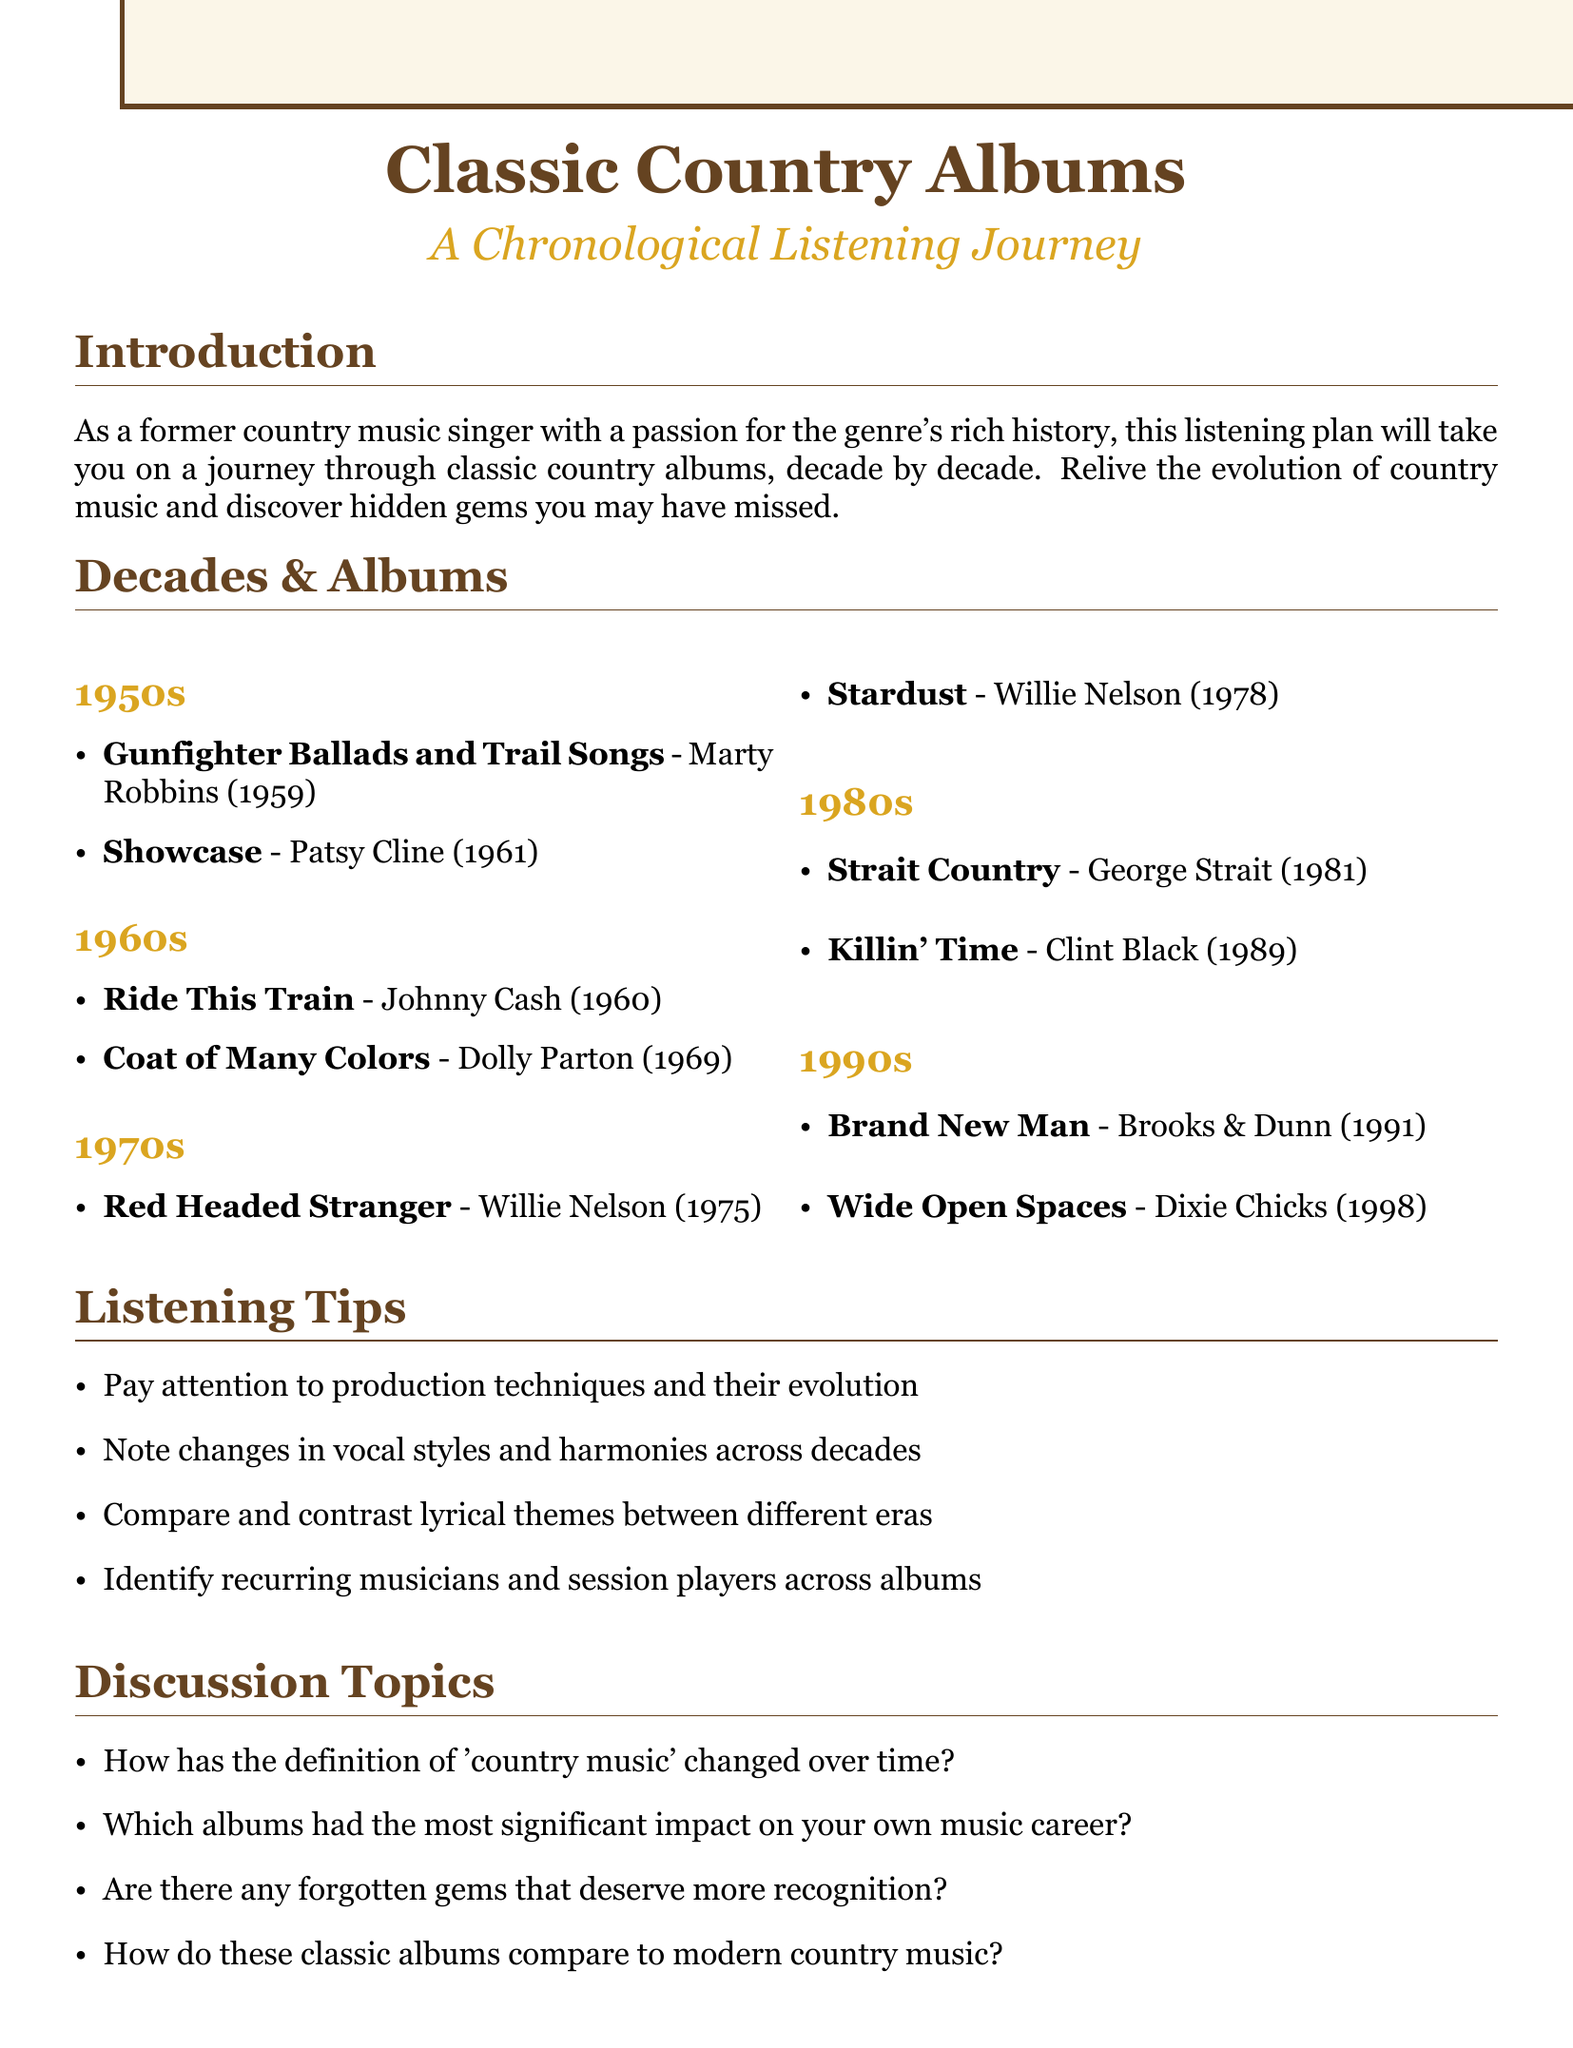What is the title of the listening session plan? The title is explicitly stated at the beginning of the document.
Answer: Chronological Listening Session Plan: Classic Country Albums by Decade Which artist released "Gunfighter Ballads and Trail Songs"? This information can be found under the 1950s album list.
Answer: Marty Robbins In which year was "Red Headed Stranger" released? The year of release is provided alongside the album title in the 1970s section.
Answer: 1975 What are two key tracks from "Coat of Many Colors"? The key tracks are listed in the details of the album.
Answer: Coat of Many Colors, Travelin' Man How many decades are covered in the listening session plan? The document lists a specific number of decades.
Answer: Five What is one listening tip provided in the document? Several tips are listed under the Listening Tips section.
Answer: Pay attention to the production techniques and how they evolve over time Which album is mentioned as part of the 1980s decade? This information is found in the 1980s section of the document.
Answer: Strait Country Name one discussion topic from the document. The discussion topics are enumerated in the corresponding section of the document.
Answer: How has the definition of 'country music' changed over time? What is included in the additional activities section? The document outlines specific activities to engage with the music further.
Answer: Create a playlist of your favorite tracks from each decade 